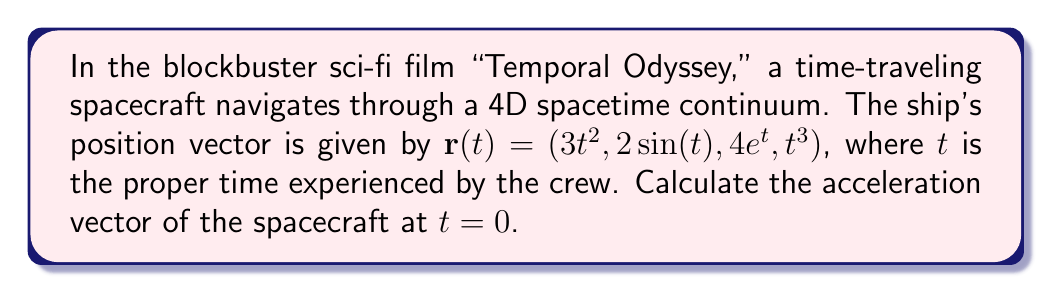Teach me how to tackle this problem. To find the acceleration vector, we need to calculate the second derivative of the position vector with respect to time. Let's break this down step-by-step:

1) First, let's find the velocity vector by taking the first derivative of $\mathbf{r}(t)$:

   $\mathbf{v}(t) = \frac{d\mathbf{r}}{dt} = (6t, 2\cos(t), 4e^t, 3t^2)$

2) Now, we need to find the acceleration vector by taking the derivative of the velocity vector:

   $\mathbf{a}(t) = \frac{d\mathbf{v}}{dt} = (6, -2\sin(t), 4e^t, 6t)$

3) We're asked to find the acceleration at $t = 0$, so let's substitute this value:

   $\mathbf{a}(0) = (6, -2\sin(0), 4e^0, 6(0))$

4) Simplify:
   - $\sin(0) = 0$
   - $e^0 = 1$

   $\mathbf{a}(0) = (6, 0, 4, 0)$

Therefore, the acceleration vector of the spacecraft at $t = 0$ is $(6, 0, 4, 0)$.
Answer: $\mathbf{a}(0) = (6, 0, 4, 0)$ 